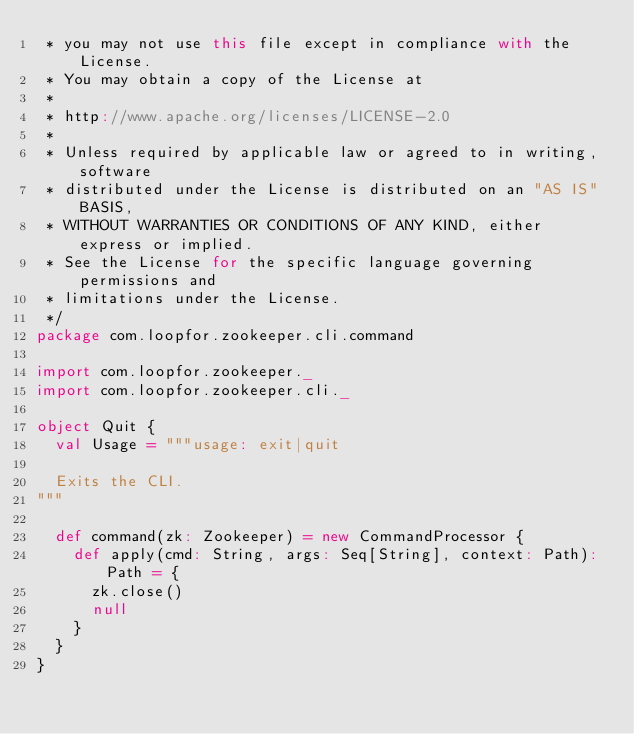Convert code to text. <code><loc_0><loc_0><loc_500><loc_500><_Scala_> * you may not use this file except in compliance with the License.
 * You may obtain a copy of the License at
 *
 * http://www.apache.org/licenses/LICENSE-2.0
 *
 * Unless required by applicable law or agreed to in writing, software
 * distributed under the License is distributed on an "AS IS" BASIS,
 * WITHOUT WARRANTIES OR CONDITIONS OF ANY KIND, either express or implied.
 * See the License for the specific language governing permissions and
 * limitations under the License.
 */
package com.loopfor.zookeeper.cli.command

import com.loopfor.zookeeper._
import com.loopfor.zookeeper.cli._

object Quit {
  val Usage = """usage: exit|quit

  Exits the CLI.
"""

  def command(zk: Zookeeper) = new CommandProcessor {
    def apply(cmd: String, args: Seq[String], context: Path): Path = {
      zk.close()
      null
    }
  }
}
</code> 